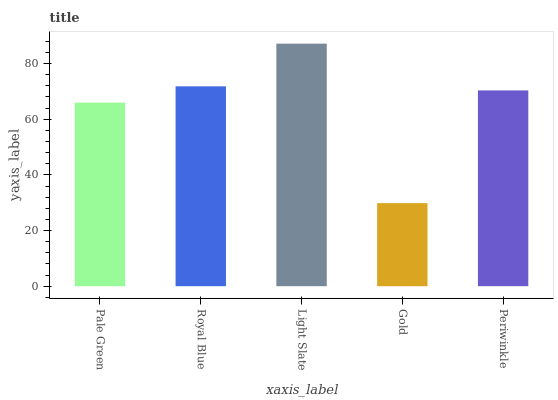Is Gold the minimum?
Answer yes or no. Yes. Is Light Slate the maximum?
Answer yes or no. Yes. Is Royal Blue the minimum?
Answer yes or no. No. Is Royal Blue the maximum?
Answer yes or no. No. Is Royal Blue greater than Pale Green?
Answer yes or no. Yes. Is Pale Green less than Royal Blue?
Answer yes or no. Yes. Is Pale Green greater than Royal Blue?
Answer yes or no. No. Is Royal Blue less than Pale Green?
Answer yes or no. No. Is Periwinkle the high median?
Answer yes or no. Yes. Is Periwinkle the low median?
Answer yes or no. Yes. Is Gold the high median?
Answer yes or no. No. Is Royal Blue the low median?
Answer yes or no. No. 